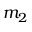<formula> <loc_0><loc_0><loc_500><loc_500>m _ { 2 }</formula> 